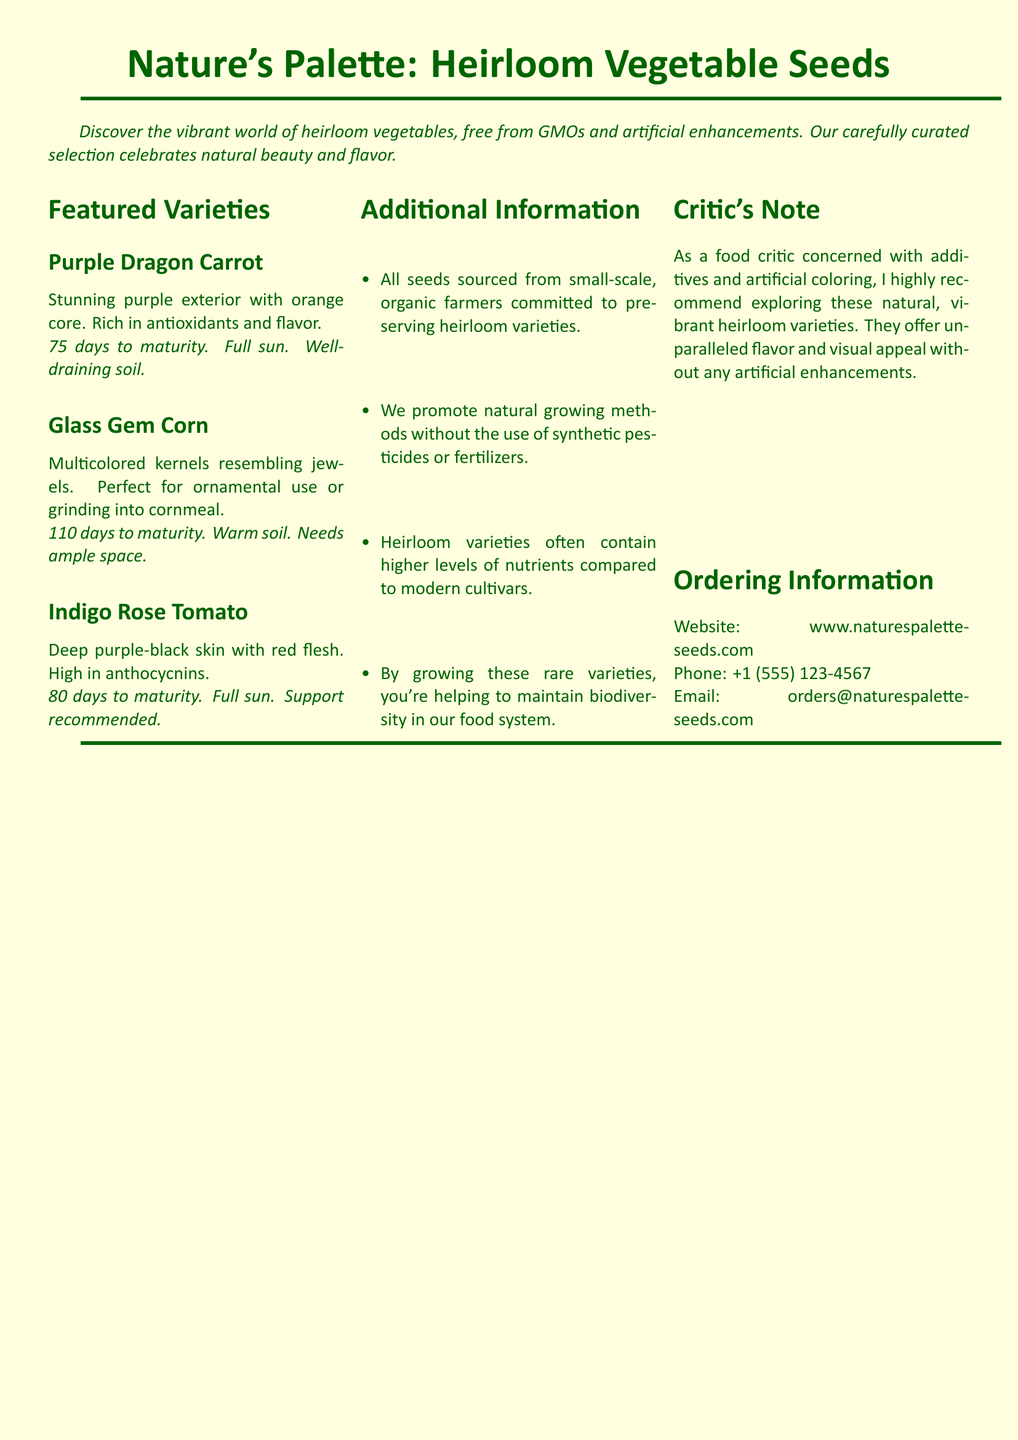What is the title of the catalog? The title of the catalog is prominently displayed at the top of the document, making it clear and easy to find.
Answer: Nature's Palette: Heirloom Vegetable Seeds How many featured varieties are listed? The document includes a section labeled "Featured Varieties" which details the number of varieties highlighted.
Answer: Three What is the maturity time for Purple Dragon Carrot? The maturity time is explicitly stated next to the variety name in the document, providing precise cultivation information.
Answer: 75 days What color are the kernels of Glass Gem Corn? The color description of the kernels is included in the section about the Glass Gem Corn variety, which indicates their unique appearance.
Answer: Multicolored What is emphasized about the seeds' sourcing? The document includes a bullet point detailing the sourcing of the seeds, highlighting the commitment to a specific agricultural practice.
Answer: Small-scale, organic farmers What benefit does the catalog state about heirloom varieties? The document mentions a specific benefit of heirloom varieties in a bullet point, showcasing their comparative advantage.
Answer: Higher levels of nutrients How is Indigo Rose Tomato described in terms of skin color? This description is found in the section related to the Indigo Rose Tomato variety, providing a visual characteristic.
Answer: Deep purple-black What is the phone number provided for orders? The contact information is clearly listed near the bottom of the document for convenience.
Answer: +1 (555) 123-4567 